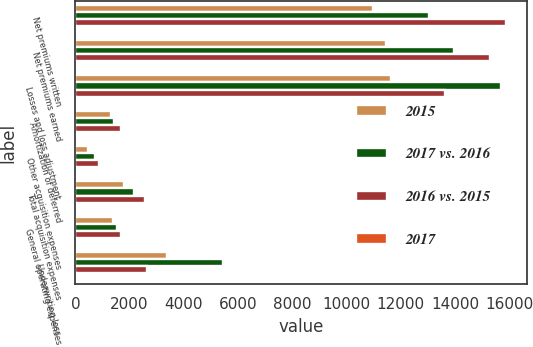<chart> <loc_0><loc_0><loc_500><loc_500><stacked_bar_chart><ecel><fcel>Net premiums written<fcel>Net premiums earned<fcel>Losses and loss adjustment<fcel>Amortization of deferred<fcel>Other acquisition expenses<fcel>Total acquisition expenses<fcel>General operating expenses<fcel>Underwriting loss<nl><fcel>2015<fcel>10973<fcel>11455<fcel>11646<fcel>1305<fcel>485<fcel>1790<fcel>1396<fcel>3377<nl><fcel>2017 vs. 2016<fcel>13026<fcel>13964<fcel>15692<fcel>1444<fcel>718<fcel>2162<fcel>1550<fcel>5440<nl><fcel>2016 vs. 2015<fcel>15866<fcel>15286<fcel>13647<fcel>1699<fcel>880<fcel>2579<fcel>1698<fcel>2638<nl><fcel>2017<fcel>16<fcel>18<fcel>26<fcel>10<fcel>32<fcel>17<fcel>10<fcel>38<nl></chart> 